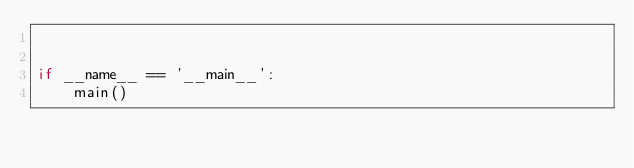Convert code to text. <code><loc_0><loc_0><loc_500><loc_500><_Python_>

if __name__ == '__main__':
    main()
</code> 